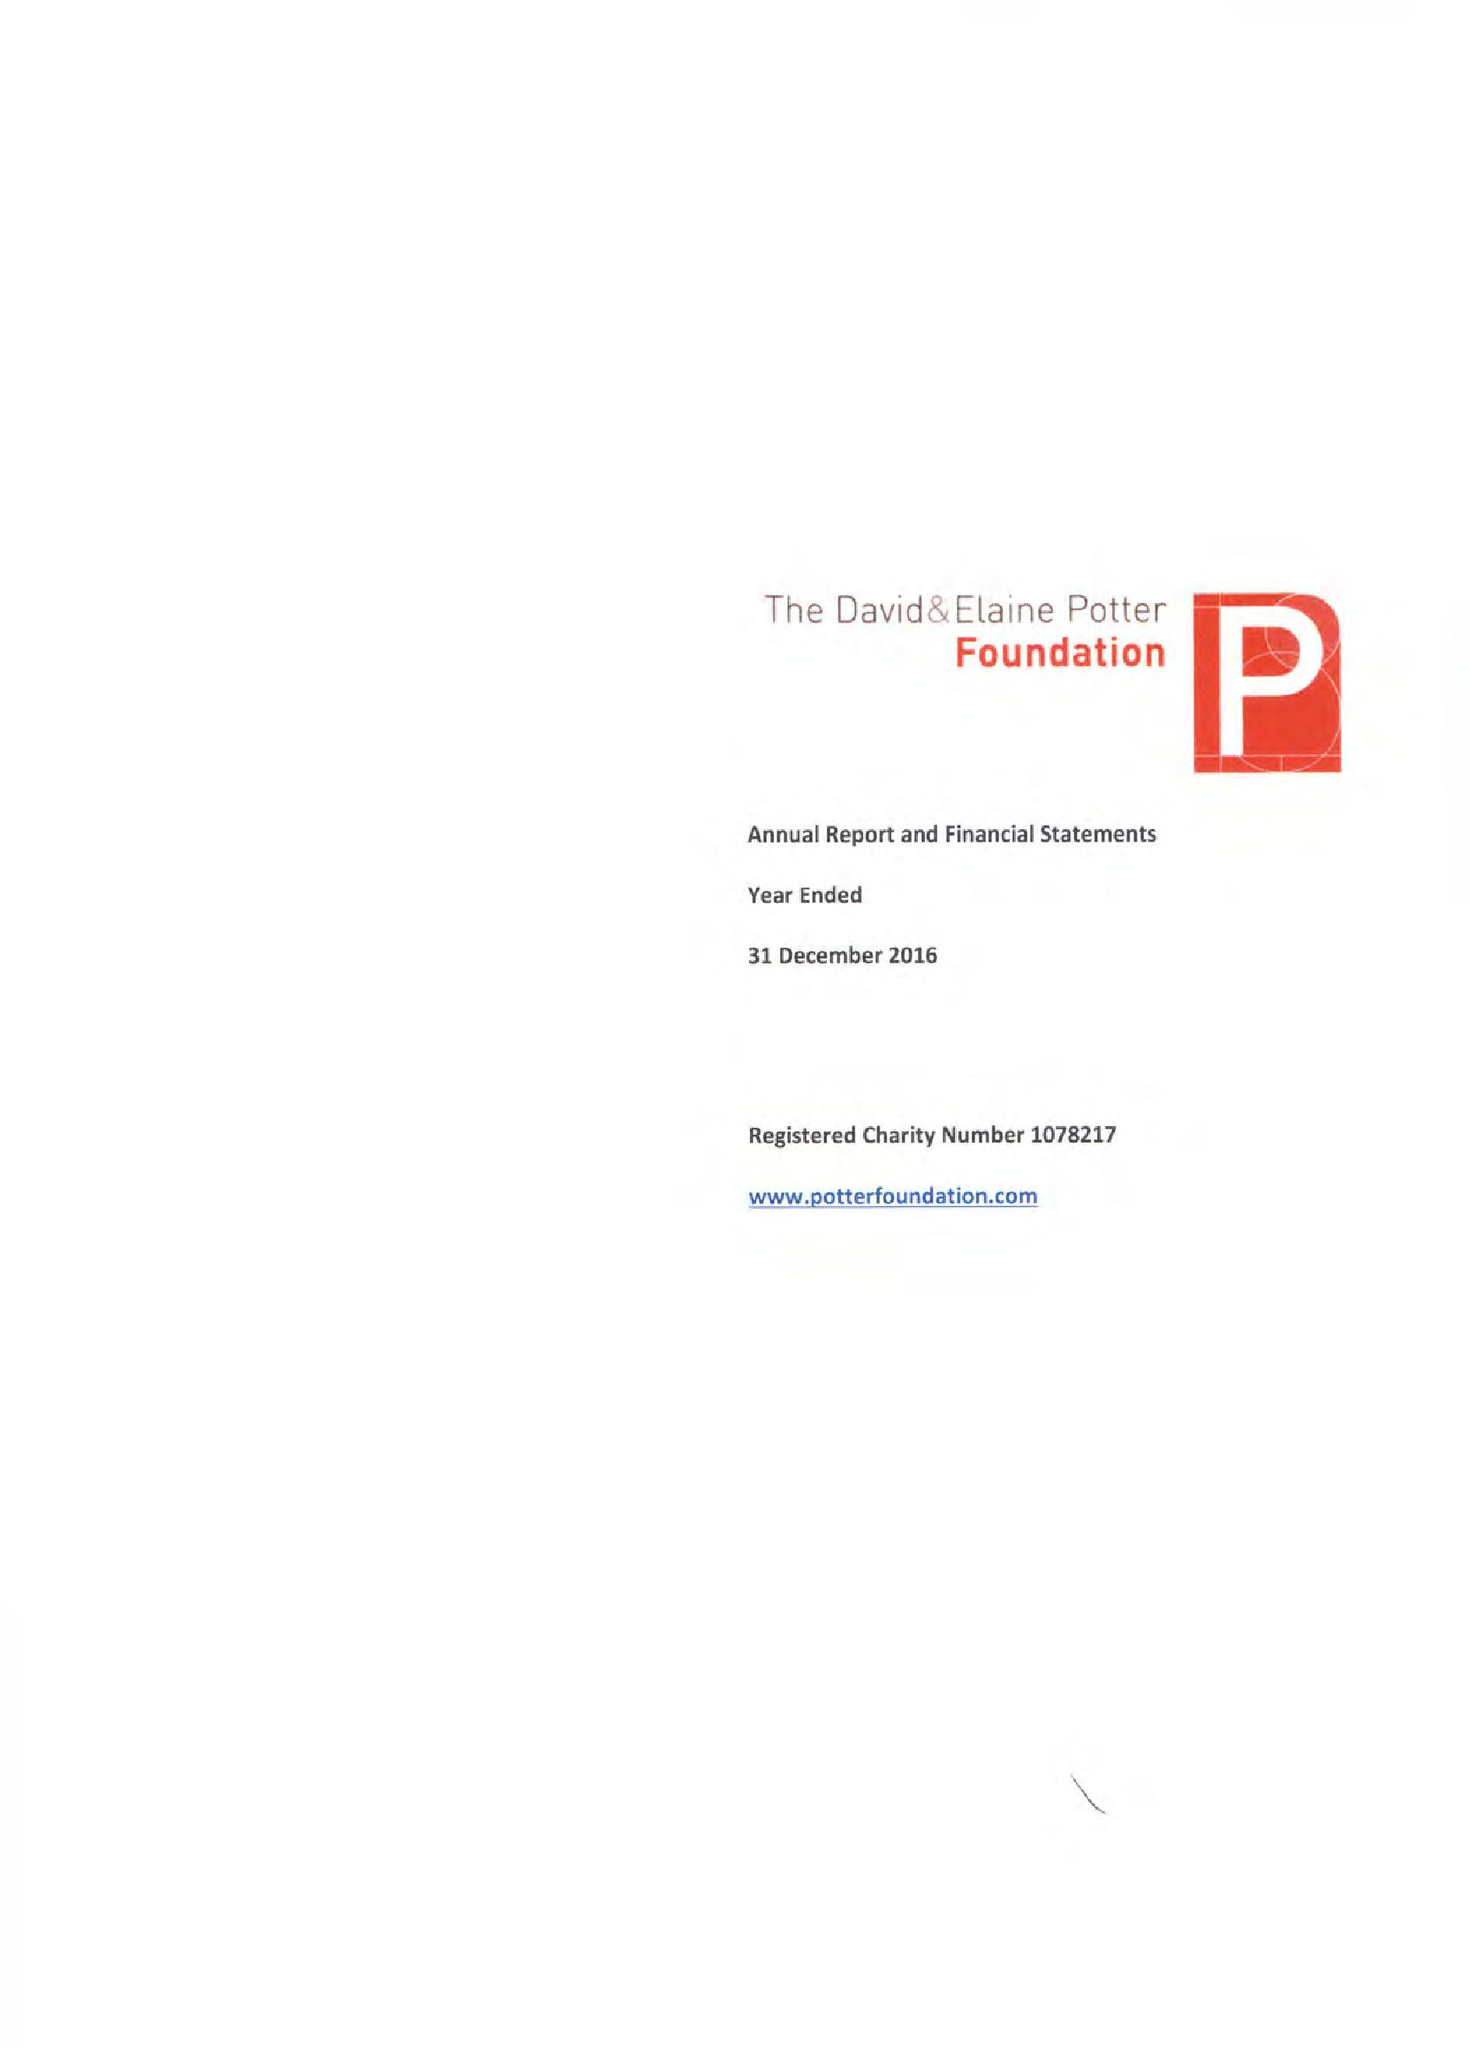What is the value for the income_annually_in_british_pounds?
Answer the question using a single word or phrase. 356769.00 